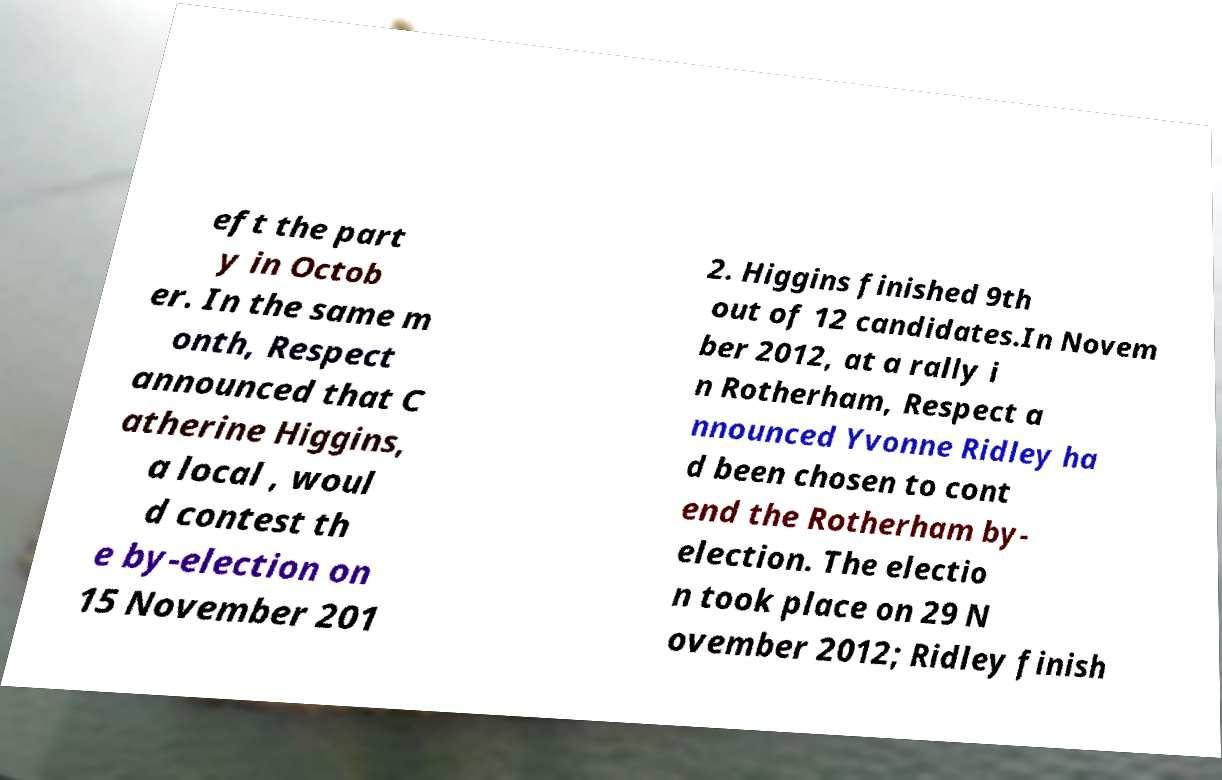Please identify and transcribe the text found in this image. eft the part y in Octob er. In the same m onth, Respect announced that C atherine Higgins, a local , woul d contest th e by-election on 15 November 201 2. Higgins finished 9th out of 12 candidates.In Novem ber 2012, at a rally i n Rotherham, Respect a nnounced Yvonne Ridley ha d been chosen to cont end the Rotherham by- election. The electio n took place on 29 N ovember 2012; Ridley finish 